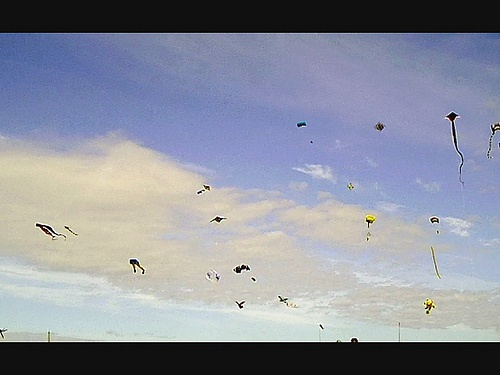Describe the objects in this image and their specific colors. I can see kite in black, lightgray, darkgray, and beige tones, kite in black, darkgray, and lavender tones, kite in black, ivory, darkgray, and gray tones, kite in black, darkgray, gray, and lightgray tones, and kite in black, ivory, darkgray, and lightgray tones in this image. 